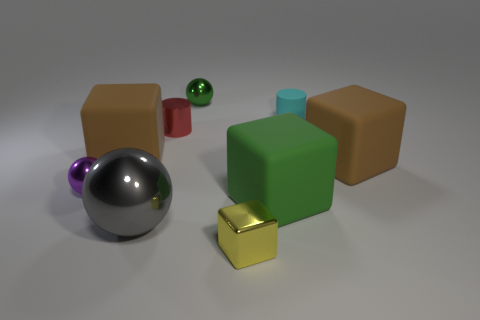Subtract all green spheres. How many spheres are left? 2 Subtract all cyan cylinders. How many brown blocks are left? 2 Subtract 1 cubes. How many cubes are left? 3 Subtract all cyan cylinders. How many cylinders are left? 1 Subtract all cylinders. How many objects are left? 7 Subtract all blue cubes. Subtract all yellow cylinders. How many cubes are left? 4 Subtract all cyan matte things. Subtract all matte cylinders. How many objects are left? 7 Add 7 green metallic objects. How many green metallic objects are left? 8 Add 1 large blue rubber things. How many large blue rubber things exist? 1 Subtract 1 cyan cylinders. How many objects are left? 8 